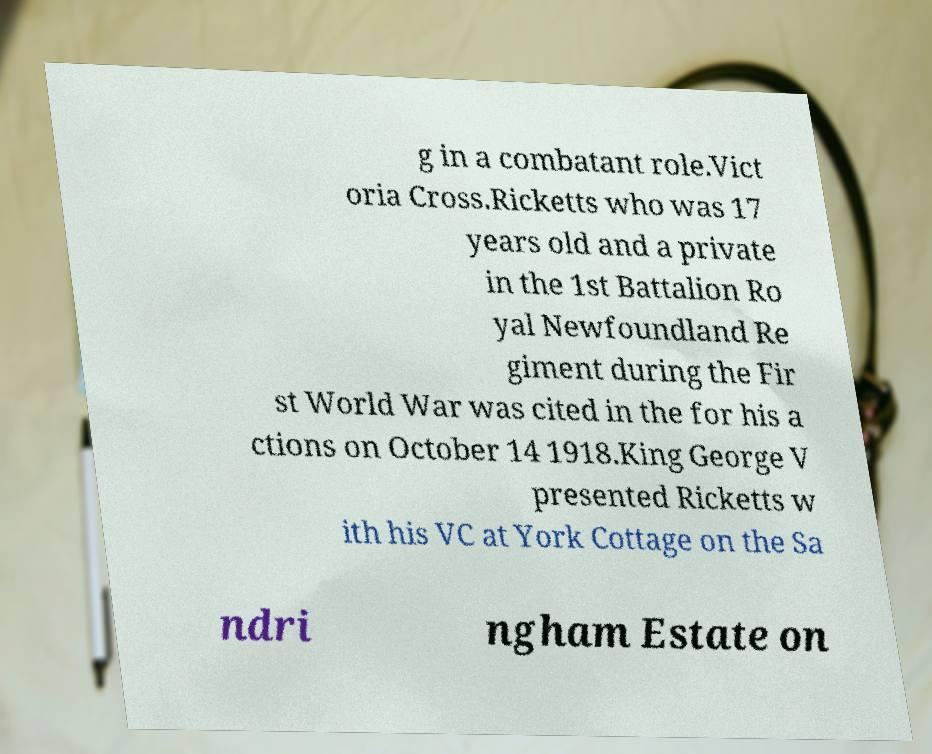Please identify and transcribe the text found in this image. g in a combatant role.Vict oria Cross.Ricketts who was 17 years old and a private in the 1st Battalion Ro yal Newfoundland Re giment during the Fir st World War was cited in the for his a ctions on October 14 1918.King George V presented Ricketts w ith his VC at York Cottage on the Sa ndri ngham Estate on 